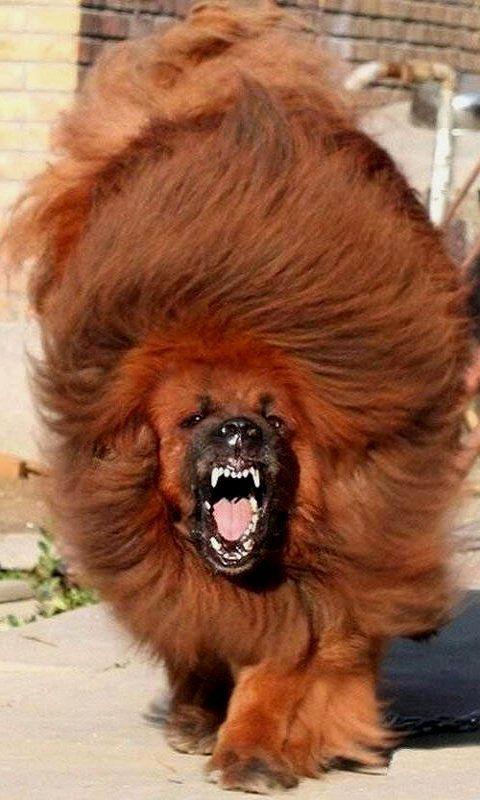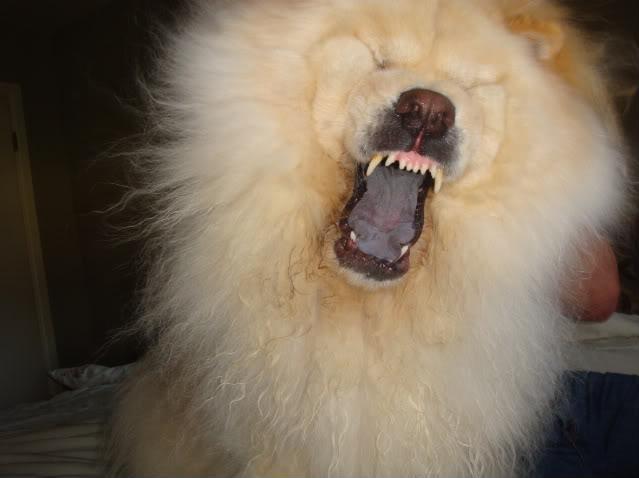The first image is the image on the left, the second image is the image on the right. For the images shown, is this caption "A female is touching a dog with her hands." true? Answer yes or no. No. The first image is the image on the left, the second image is the image on the right. Given the left and right images, does the statement "The image on the left contains a person holding onto a dog." hold true? Answer yes or no. No. 